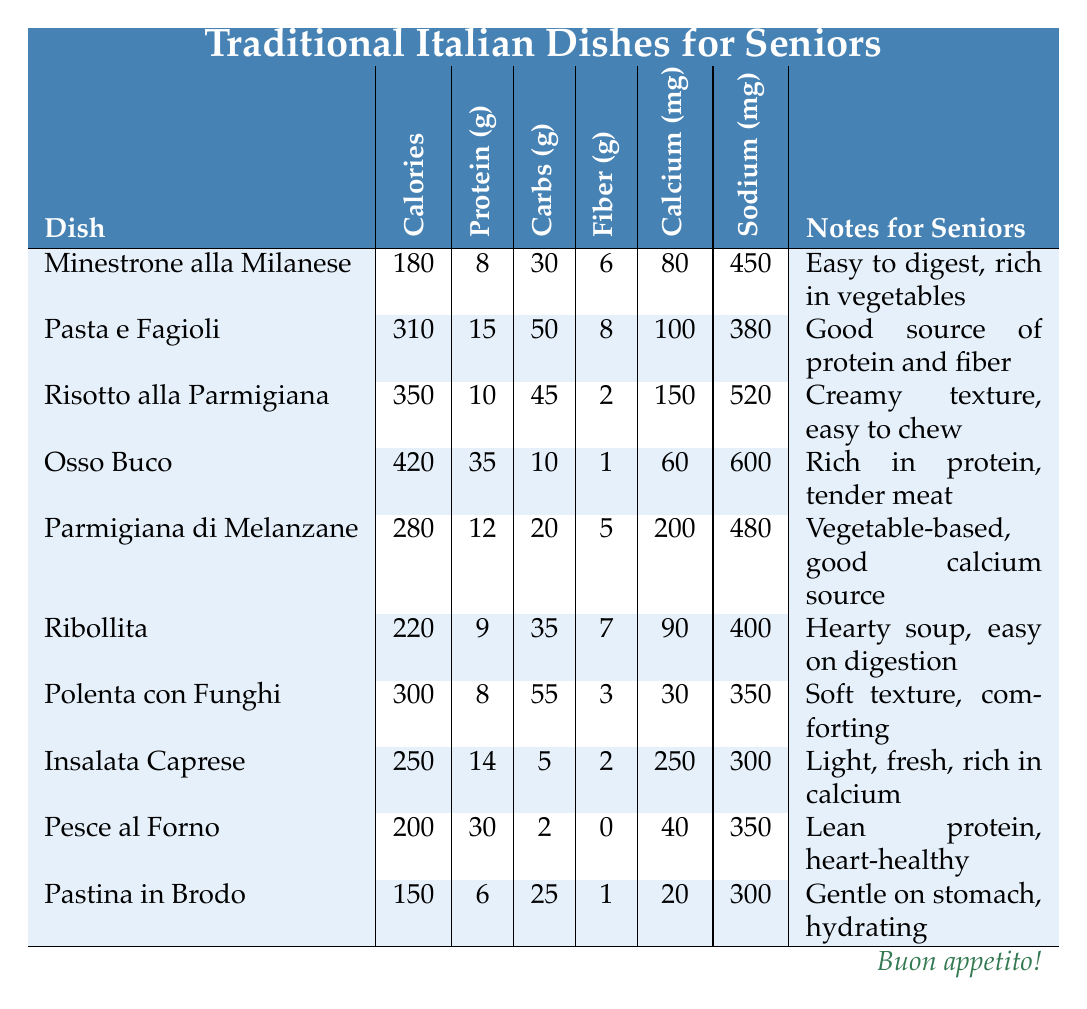What dish has the highest sodium content? By reviewing the sodium values in the table, we see that Osso Buco has 600 mg of sodium, which is the highest among all dishes.
Answer: Osso Buco What is the total protein content of Pasta e Fagioli and Osso Buco combined? The protein content of Pasta e Fagioli is 15 g, and for Osso Buco, it is 35 g. Adding them together gives 15 g + 35 g = 50 g.
Answer: 50 g Is Risotto alla Parmigiana high in calcium? Looking at the calcium values, Risotto alla Parmigiana has 150 mg of calcium, which is not considered high compared to dishes like Insalata Caprese which has 250 mg. Thus, the statement is false.
Answer: False How many grams of carbohydrates does Ribollita have? Referring to the table, Ribollita has 35 grams of carbohydrates listed directly under its entry.
Answer: 35 g Which dish is noted as a good source of fiber and is easy to digest? The dish Minestrone alla Milanese is noted for being easy to digest and it contains 6 grams of fiber.
Answer: Minestrone alla Milanese What is the average calcium content of the dishes listed? To find the average, we first sum the calcium content: 80 + 100 + 150 + 60 + 200 + 90 + 30 + 250 + 40 + 20 = 1020 mg. There are 10 dishes, so we divide 1020 by 10, which results in 102 mg per dish on average.
Answer: 102 mg Is the calorie content of Pastina in Brodo less than 200 calories? Checking the table, Pastina in Brodo has 150 calories, which is indeed less than 200. Therefore, the answer is true.
Answer: True What dish contains the most protein and how much protein does it have? The dish Osso Buco contains the most protein at 35 grams per serving according to the protein content listed.
Answer: Osso Buco, 35 g Is Insalata Caprese identified as low in sodium? Insalata Caprese has 300 mg of sodium, which can be considered low compared to others like Osso Buco with 600 mg. Thus, it can indeed be regarded as low in sodium.
Answer: True 